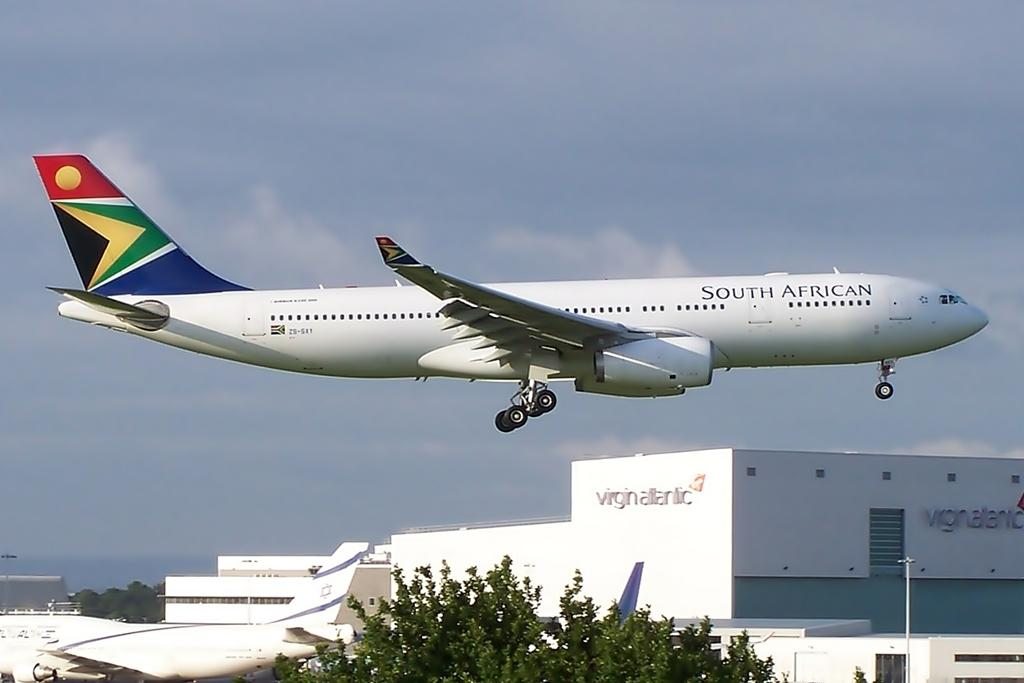<image>
Write a terse but informative summary of the picture. a blue and white airplane with the south african airlines printed on it. 